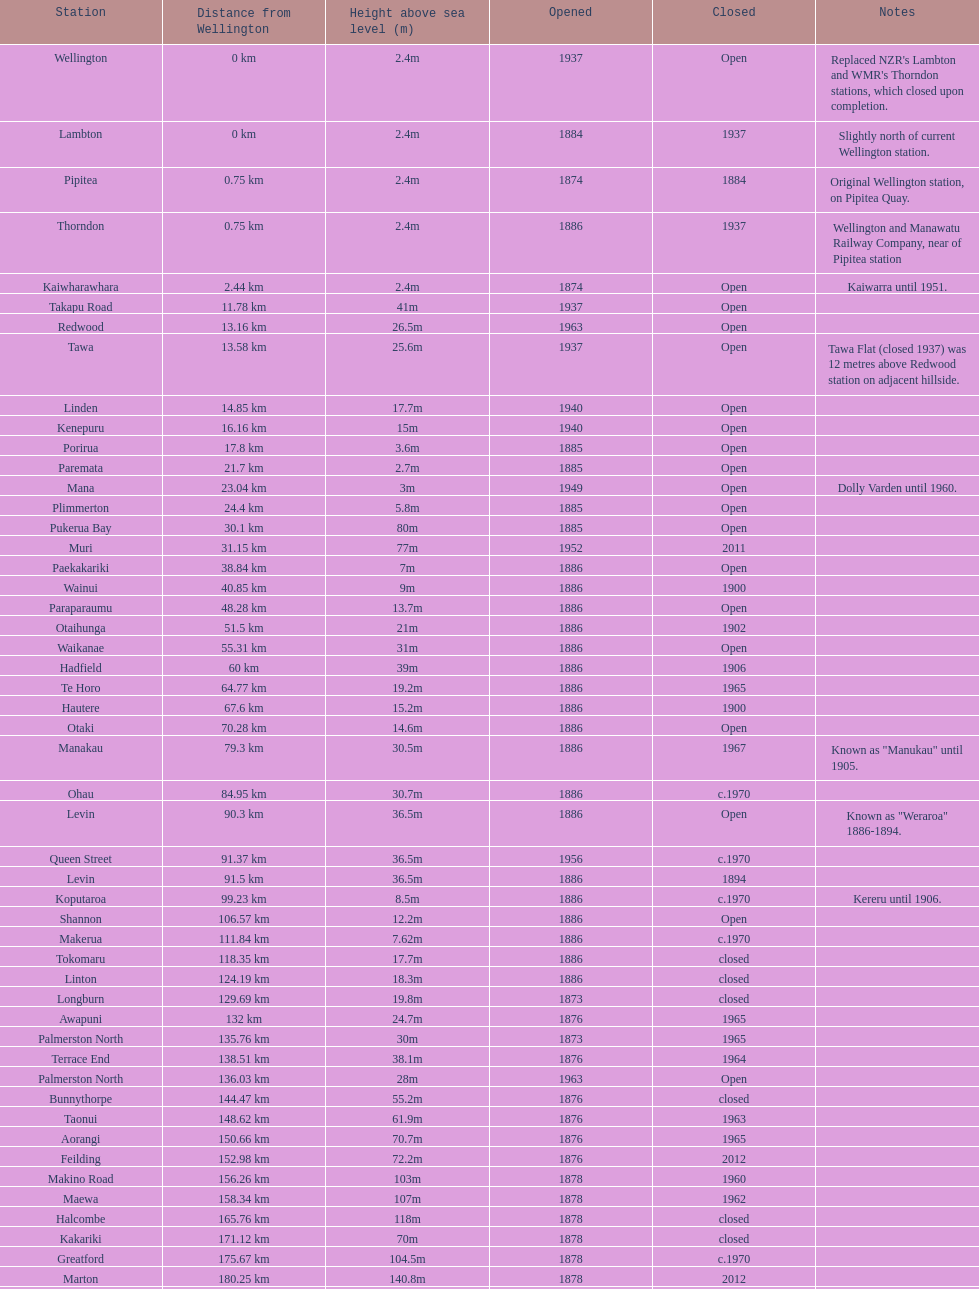What is the elevation difference between takapu road station and wellington station? 38.6m. 